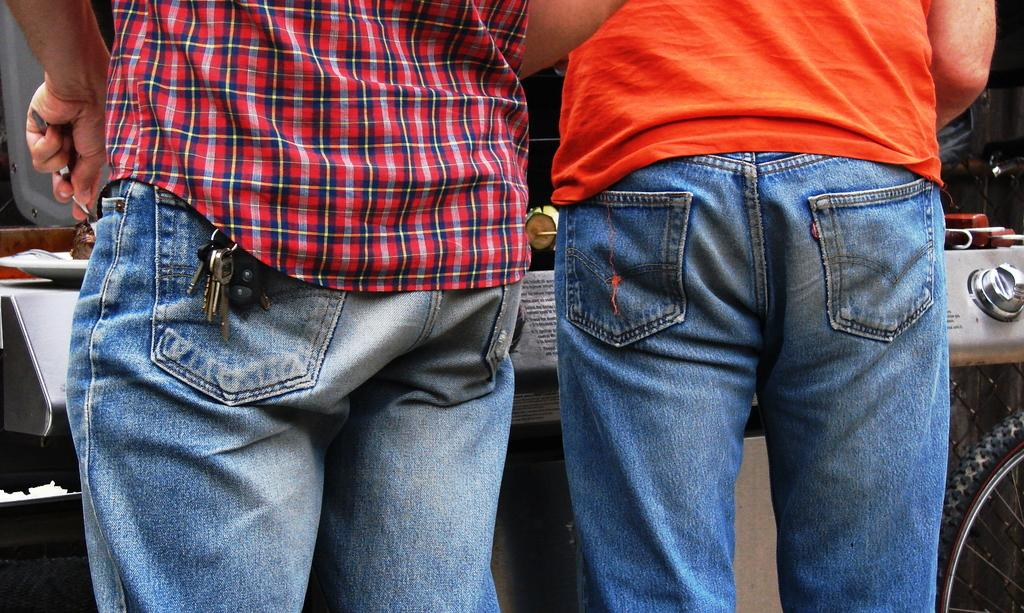What can be seen in the foreground of the image? There are persons standing in the front of the image. What is located in the background of the image? There is a vehicle in the background of the image. What type of rhythm is being played by the spoon in the image? There is no spoon present in the image, and therefore no rhythm can be associated with it. 